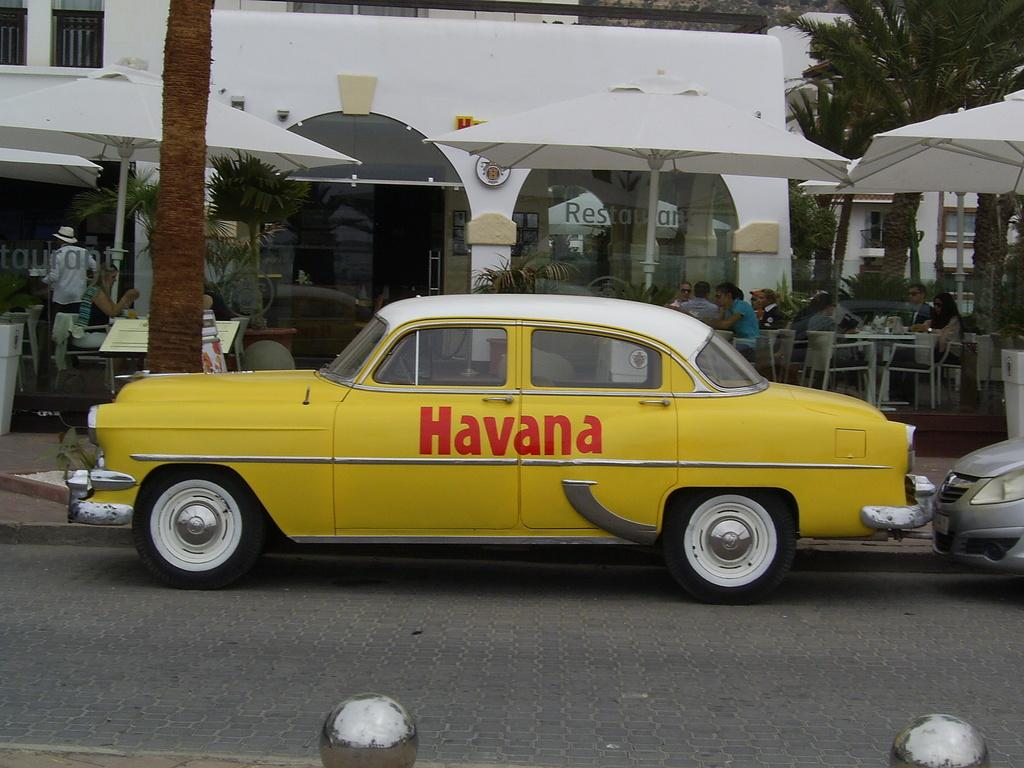Provide a one-sentence caption for the provided image. The yellow taxi cab advertising the one and only Havana. 